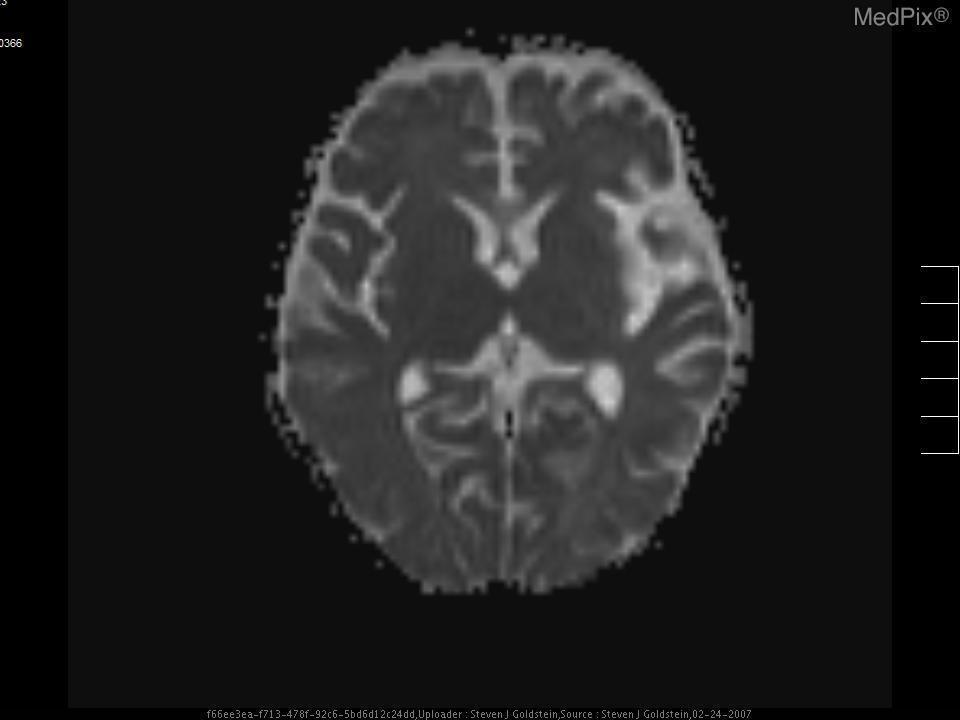Is there an acute bleed present?
Answer briefly. Necrotic tissue. What does the brighter outer ring of the lesion represent?
Write a very short answer. Necrosis. What is indicated by the bright ring around the lesion?
Give a very brief answer. Necrosis. Are any ventricles visualized on this image?
Short answer required. Yes. Can you see ventricles?
Answer briefly. Yes. Is the lesion on the patient's right or left side?
Keep it brief. Left side. Where on the image is the lesion?
Give a very brief answer. Left temporal lobe. 